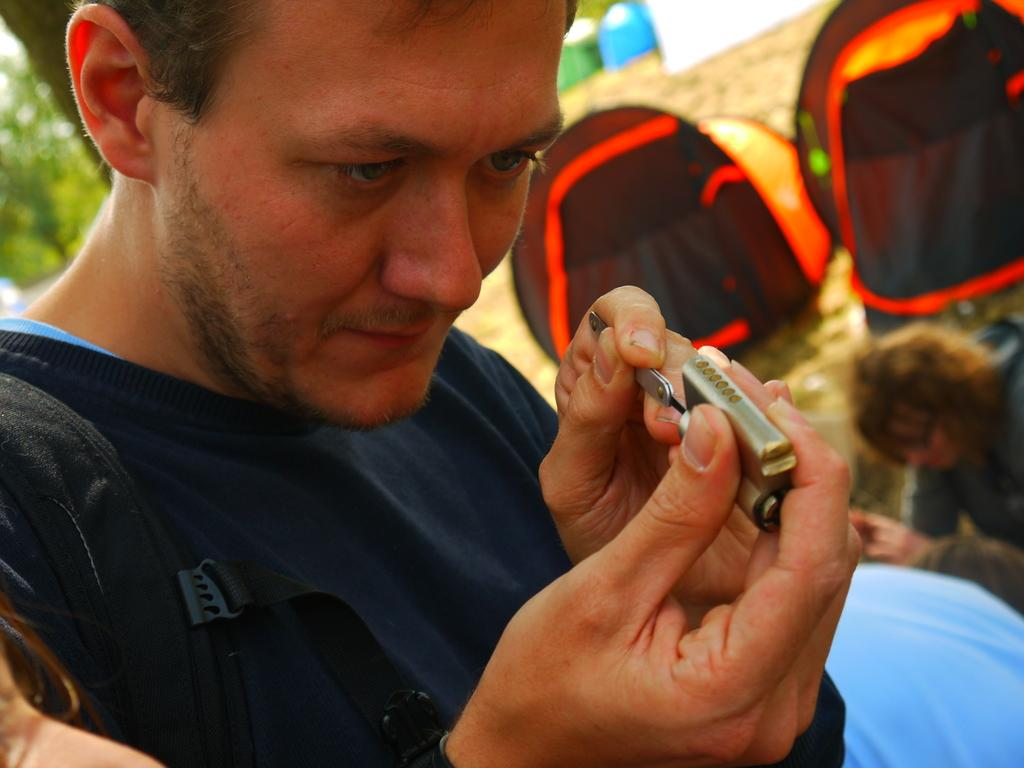What is the man in the foreground holding in his hand? The man in the foreground is holding a lock in his hand. Can you describe the people in the background? There are two persons in the background. What can be seen beneath the people in the image? The ground is visible in the image. What type of natural environment is visible in the background? There are trees in the background. When was the image taken? The image was taken during the day. How does the man's uncle run towards him in the image? There is no mention of an uncle or running in the image; the man is simply holding a lock in his hand. 